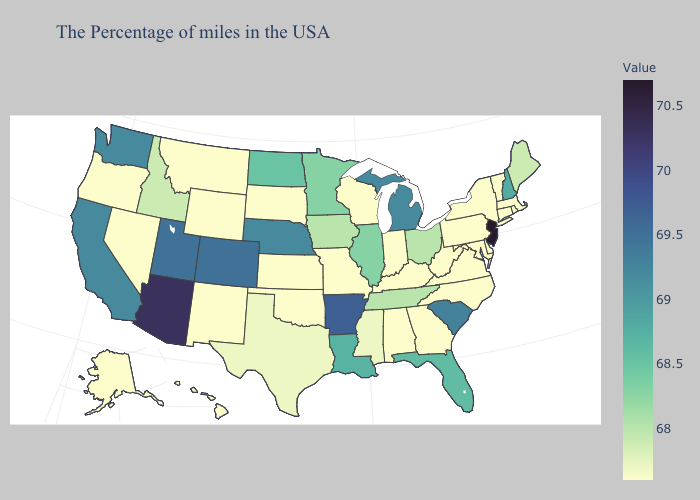Does Vermont have the lowest value in the Northeast?
Concise answer only. Yes. Among the states that border South Dakota , which have the lowest value?
Concise answer only. Wyoming, Montana. Does Oklahoma have the lowest value in the South?
Answer briefly. Yes. Does New Jersey have the highest value in the USA?
Answer briefly. Yes. Which states have the lowest value in the South?
Answer briefly. Delaware, Maryland, Virginia, North Carolina, West Virginia, Georgia, Kentucky, Alabama, Oklahoma. 